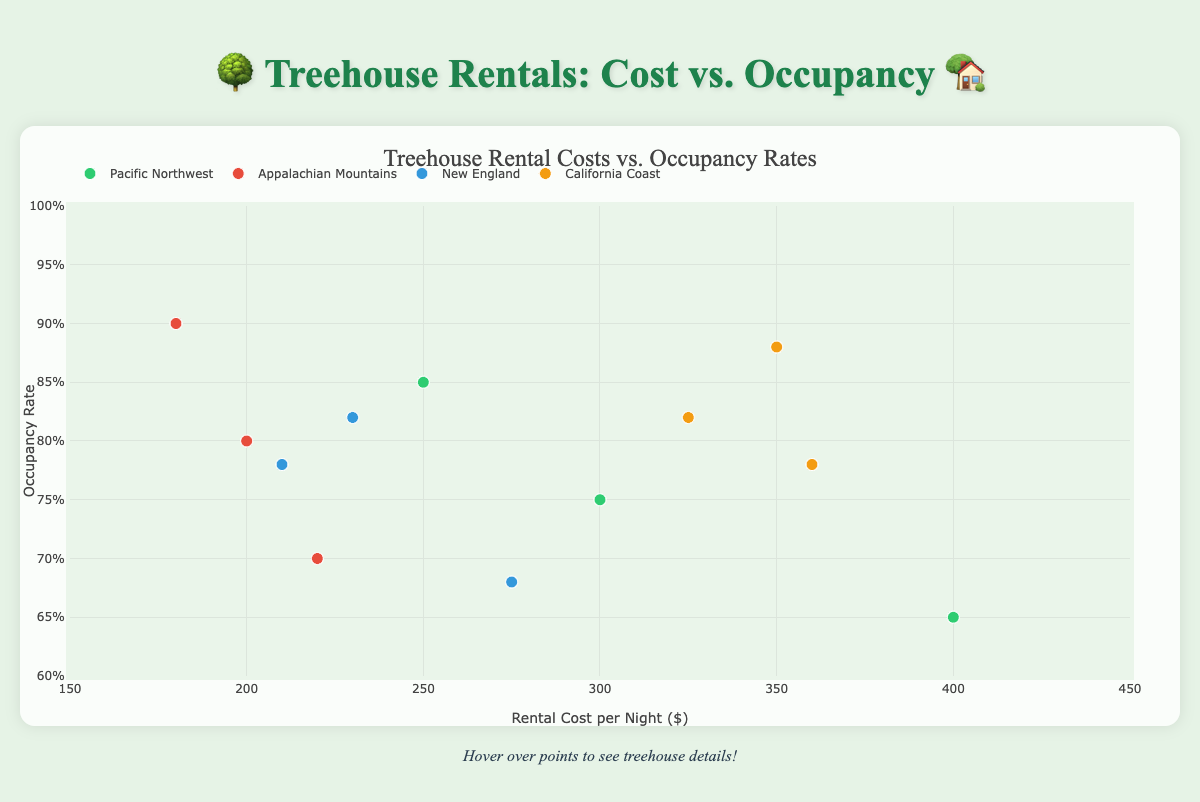What is the title of the plot? The title is located at the top center of the plot and reads "Treehouse Rental Costs vs. Occupancy Rates"
Answer: Treehouse Rental Costs vs. Occupancy Rates What is the range of rental costs per night displayed on the x-axis? The x-axis represents the rental cost per night and ranges from $150 to $450 as indicated by the tick marks.
Answer: $150 to $450 Which region has the treehouse with the highest occupancy rate? The treehouse with the highest occupancy rate has a rate of 90%, represented by a point at occupancy 0.90 on the y-axis. It belongs to the Appalachian Mountains region ("Forest Fantasy").
Answer: Appalachian Mountains Which region has the treehouse with the highest rental cost per night? The treehouse with the highest rental cost per night is the one at $400, which belongs to the Pacific Northwest region ("Whispering Pines Hideaway").
Answer: Pacific Northwest How many data points are there for the California Coast region? The California Coast region has three different treehouses, each represented by a separate point on the scatter plot.
Answer: 3 Which region has the lowest average occupancy rate? Calculate the average occupancy rates per region: 
Pacific Northwest: (0.75 + 0.85 + 0.65)/3 = 0.75,
Appalachian Mountains: (0.80 + 0.90 + 0.70)/3 = 0.80,
New England: (0.82 + 0.78 + 0.68)/3 ≈ 0.76,
California Coast: (0.88 + 0.82 + 0.78)/3 ≈ 0.83. 
The Pacific Northwest has the lowest average occupancy rate.
Answer: Pacific Northwest Do any treehouses in the New England region have higher occupancy rates than all treehouses in the Pacific Northwest region? Compare the occupancy rates of both regions: 
New England treehouses have occupancy rates of 0.82, 0.78, and 0.68.
Pacific Northwest treehouses have occupancy rates of 0.75, 0.85, and 0.65. 
None of the treehouses in New England have occupancy rates higher than the highest rate (0.85) in the Pacific Northwest.
Answer: No Which treehouse has the highest rental cost and what is its occupancy rate? The treehouse with the highest rental cost is "Whispering Pines Hideaway" with $400 per night. Its occupancy rate is 0.65.
Answer: Whispering Pines Hideaway, 0.65 Is there a correlation between rental cost and occupancy rate in the California Coast region? Examine the points in the California Coast region:
Ocean View Oasis: 350, 0.88
Seaside Serendipity: 325, 0.82
Cliffside Haven: 360, 0.78.
Generally, as the rental cost increases, the occupancy rate decreases, indicating a negative correlation.
Answer: Negative correlation 